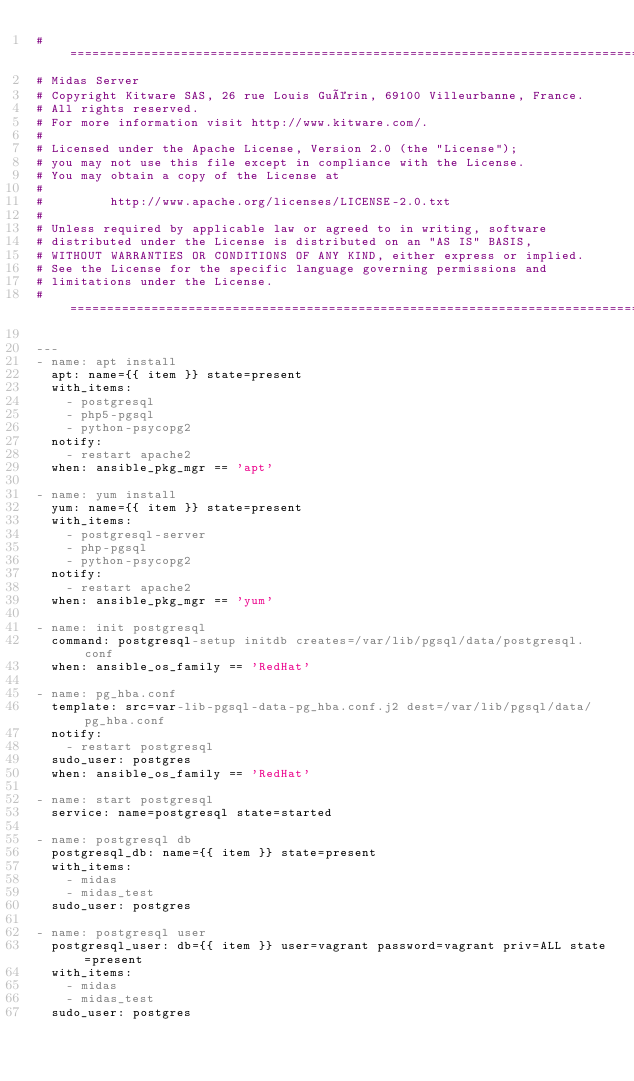Convert code to text. <code><loc_0><loc_0><loc_500><loc_500><_YAML_>#=============================================================================
# Midas Server
# Copyright Kitware SAS, 26 rue Louis Guérin, 69100 Villeurbanne, France.
# All rights reserved.
# For more information visit http://www.kitware.com/.
#
# Licensed under the Apache License, Version 2.0 (the "License");
# you may not use this file except in compliance with the License.
# You may obtain a copy of the License at
#
#         http://www.apache.org/licenses/LICENSE-2.0.txt
#
# Unless required by applicable law or agreed to in writing, software
# distributed under the License is distributed on an "AS IS" BASIS,
# WITHOUT WARRANTIES OR CONDITIONS OF ANY KIND, either express or implied.
# See the License for the specific language governing permissions and
# limitations under the License.
#=============================================================================

---
- name: apt install
  apt: name={{ item }} state=present
  with_items:
    - postgresql
    - php5-pgsql
    - python-psycopg2
  notify:
    - restart apache2
  when: ansible_pkg_mgr == 'apt'

- name: yum install
  yum: name={{ item }} state=present
  with_items:
    - postgresql-server
    - php-pgsql
    - python-psycopg2
  notify:
    - restart apache2
  when: ansible_pkg_mgr == 'yum'

- name: init postgresql
  command: postgresql-setup initdb creates=/var/lib/pgsql/data/postgresql.conf
  when: ansible_os_family == 'RedHat'

- name: pg_hba.conf
  template: src=var-lib-pgsql-data-pg_hba.conf.j2 dest=/var/lib/pgsql/data/pg_hba.conf
  notify:
    - restart postgresql
  sudo_user: postgres
  when: ansible_os_family == 'RedHat'

- name: start postgresql
  service: name=postgresql state=started

- name: postgresql db
  postgresql_db: name={{ item }} state=present
  with_items:
    - midas
    - midas_test
  sudo_user: postgres

- name: postgresql user
  postgresql_user: db={{ item }} user=vagrant password=vagrant priv=ALL state=present
  with_items:
    - midas
    - midas_test
  sudo_user: postgres
</code> 